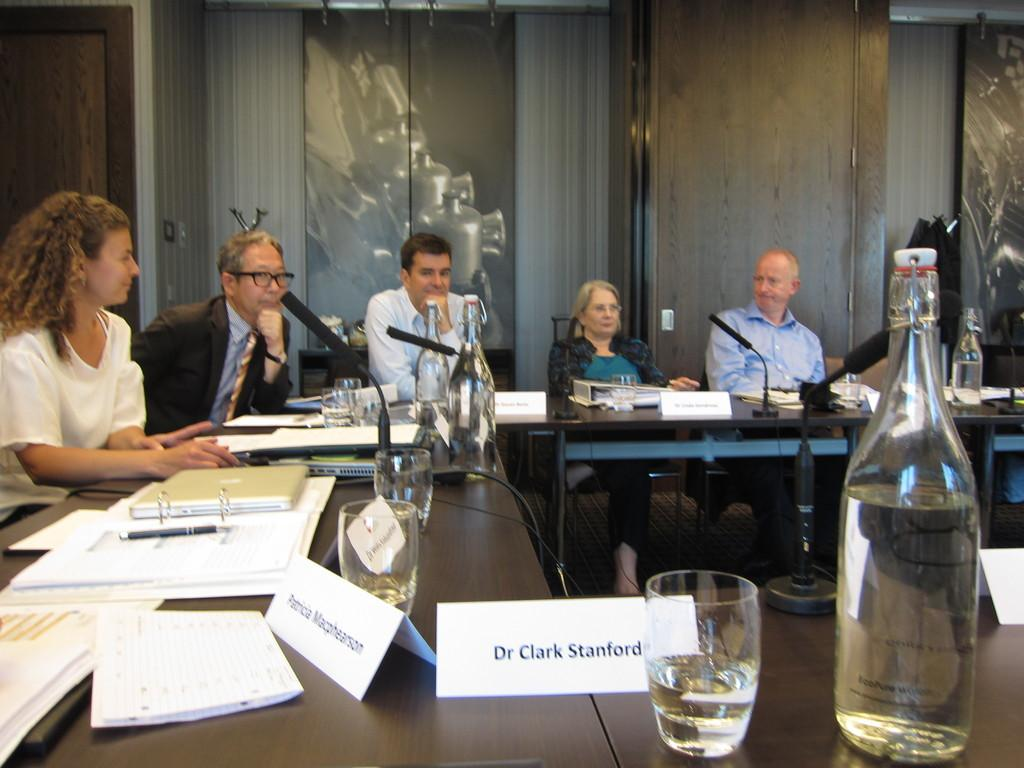<image>
Describe the image concisely. the name clark that is on a name tag 